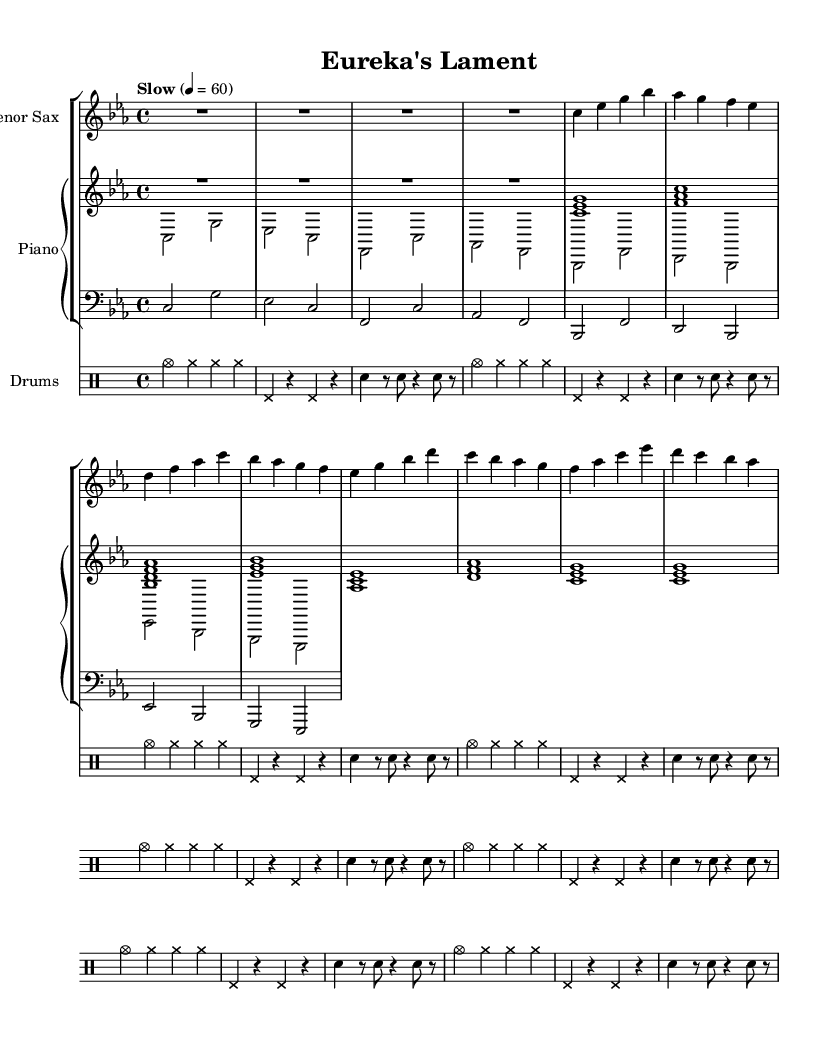What is the key signature of this music? The key signature is indicated by the absence of sharps or flats on the staff. The presence of only natural notes suggests this music is in C minor, which has three flats. However, since we observe the notes closely, the presence of E-flat, and the lack of any other notes typically associated with D-flat, points toward C minor as the primary tonality.
Answer: C minor What is the time signature of this music? The time signature is typically noted at the beginning of the staff. Here, we see a "4/4," which means there are four beats in a measure and the quarter note gets one beat. This is confirmed by the structure of the measures that include four beats grouped together.
Answer: 4/4 What is the tempo marking for this piece? The tempo is usually indicated at the beginning of the piece, and in this case, it reads "Slow" at a quarter note equals 60 beats per minute. This indicates that the music should be played leisurely.
Answer: Slow How many measures does the saxophone part contain? By examining the saxophone notes, we count the bars or segments of music between the double bar lines. Here, it is evident that there are eight distinct measures in the saxophone part as divided uniformly within the score.
Answer: Eight What instruments are featured in this composition? The instruments used are indicated at the beginning of the score. We find a tenor saxophone for melodic lines, a piano for harmonic support, a bass for foundational bass lines, and drums for rhythmic accompaniment. Together, they create a typical jazz ensemble.
Answer: Tenor Sax, Piano, Bass, Drums Which voicing is used in the piano part? The piano part explicitly shows two separate voices: the right-hand voice typically plays melodies or harmonies, while the left-hand voice generally provides a bass line or chordal support. Analyzing the notation confirms that both voices are present in the score, utilized for creating a rich texture in a jazz ballad.
Answer: Right and Left 